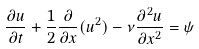Convert formula to latex. <formula><loc_0><loc_0><loc_500><loc_500>\frac { \partial u } { \partial t } + \frac { 1 } { 2 } \frac { \partial } { \partial x } ( u ^ { 2 } ) - \nu \frac { \partial ^ { 2 } u } { \partial x ^ { 2 } } = \psi</formula> 